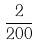<formula> <loc_0><loc_0><loc_500><loc_500>\frac { 2 } { 2 0 0 }</formula> 